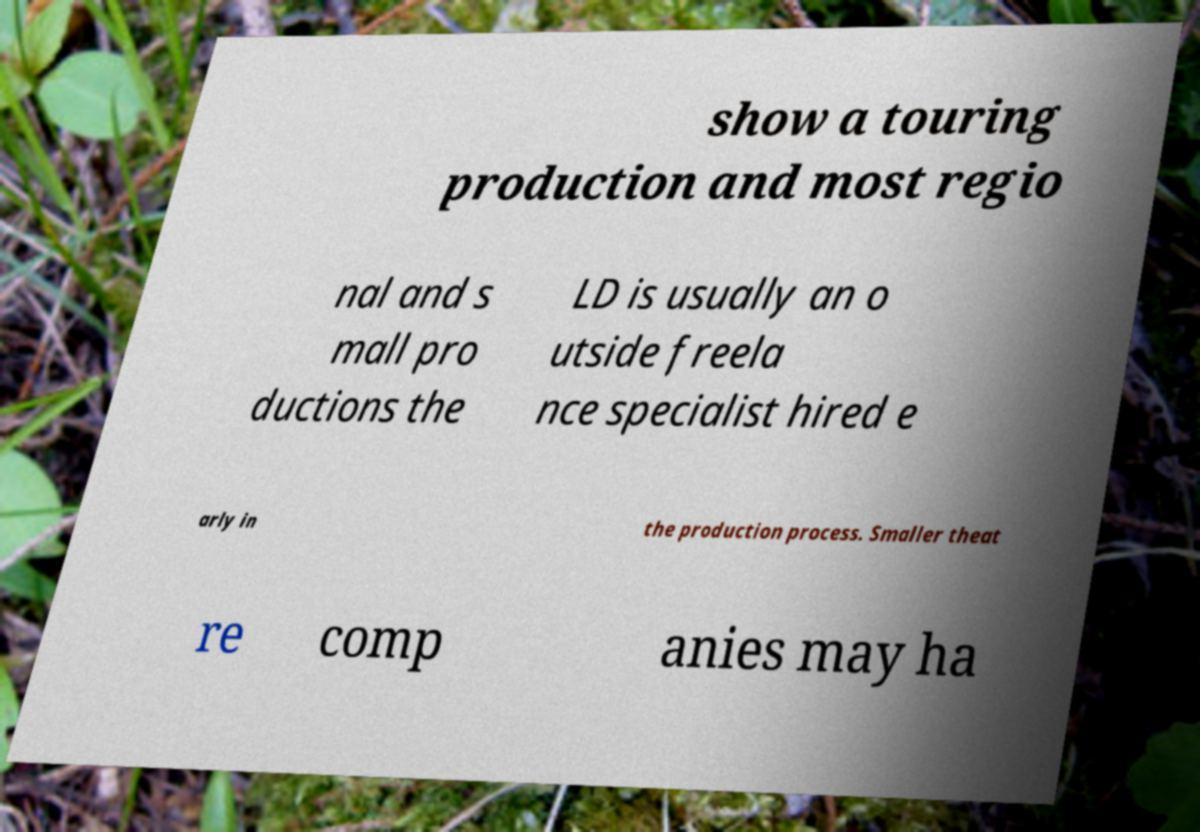There's text embedded in this image that I need extracted. Can you transcribe it verbatim? show a touring production and most regio nal and s mall pro ductions the LD is usually an o utside freela nce specialist hired e arly in the production process. Smaller theat re comp anies may ha 